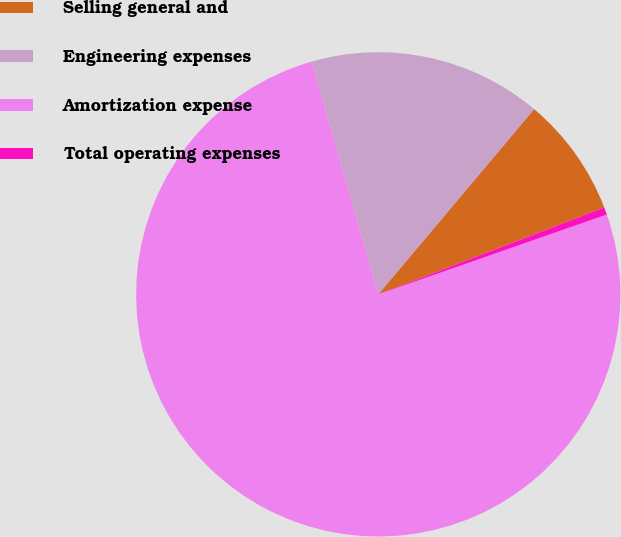Convert chart. <chart><loc_0><loc_0><loc_500><loc_500><pie_chart><fcel>Selling general and<fcel>Engineering expenses<fcel>Amortization expense<fcel>Total operating expenses<nl><fcel>8.03%<fcel>15.57%<fcel>75.91%<fcel>0.49%<nl></chart> 